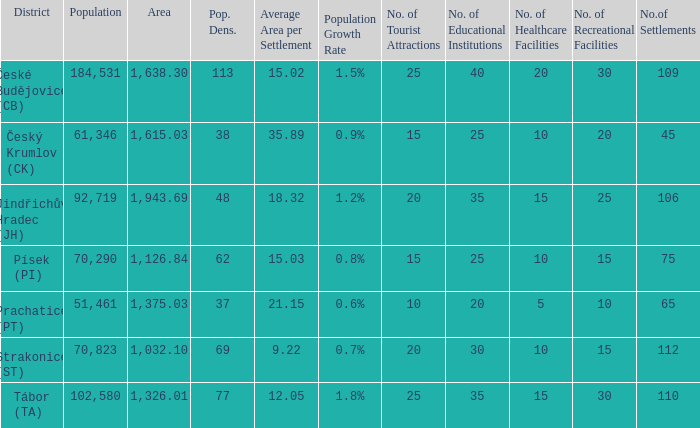How many settlements are in český krumlov (ck) with a population density higher than 38? None. Parse the full table. {'header': ['District', 'Population', 'Area', 'Pop. Dens.', 'Average Area per Settlement', 'Population Growth Rate', 'No. of Tourist Attractions', 'No. of Educational Institutions', 'No. of Healthcare Facilities', 'No. of Recreational Facilities', 'No.of Settlements'], 'rows': [['České Budějovice (CB)', '184,531', '1,638.30', '113', '15.02', '1.5%', '25', '40', '20', '30', '109'], ['Český Krumlov (CK)', '61,346', '1,615.03', '38', '35.89', '0.9%', '15', '25', '10', '20', '45'], ['Jindřichův Hradec (JH)', '92,719', '1,943.69', '48', '18.32', '1.2%', '20', '35', '15', '25', '106'], ['Písek (PI)', '70,290', '1,126.84', '62', '15.03', '0.8%', '15', '25', '10', '15', '75'], ['Prachatice (PT)', '51,461', '1,375.03', '37', '21.15', '0.6%', '10', '20', '5', '10', '65'], ['Strakonice (ST)', '70,823', '1,032.10', '69', '9.22', '0.7%', '20', '30', '10', '15', '112'], ['Tábor (TA)', '102,580', '1,326.01', '77', '12.05', '1.8%', '25', '35', '15', '30', '110']]} 